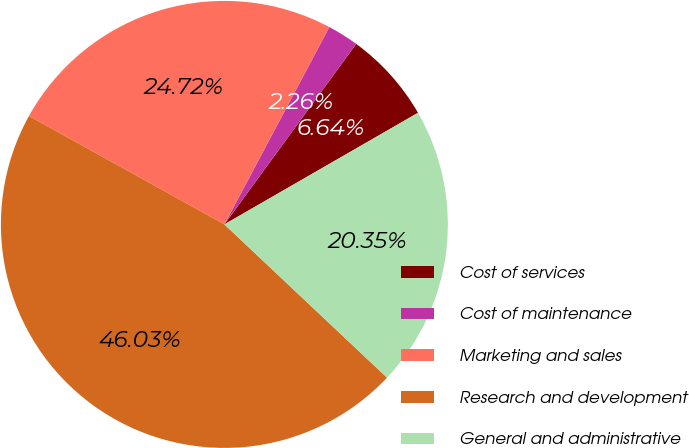Convert chart to OTSL. <chart><loc_0><loc_0><loc_500><loc_500><pie_chart><fcel>Cost of services<fcel>Cost of maintenance<fcel>Marketing and sales<fcel>Research and development<fcel>General and administrative<nl><fcel>6.64%<fcel>2.26%<fcel>24.72%<fcel>46.03%<fcel>20.35%<nl></chart> 